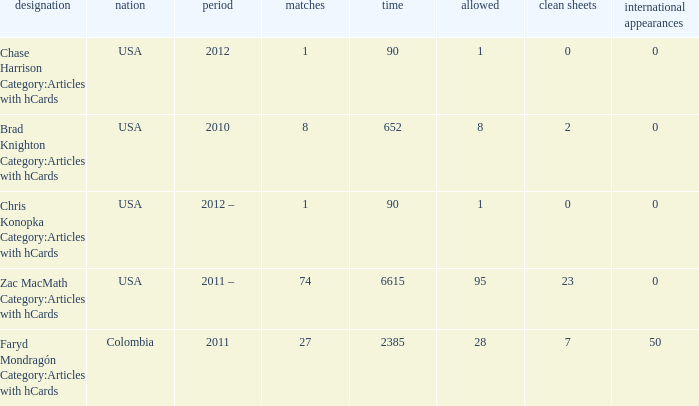Can you parse all the data within this table? {'header': ['designation', 'nation', 'period', 'matches', 'time', 'allowed', 'clean sheets', 'international appearances'], 'rows': [['Chase Harrison Category:Articles with hCards', 'USA', '2012', '1', '90', '1', '0', '0'], ['Brad Knighton Category:Articles with hCards', 'USA', '2010', '8', '652', '8', '2', '0'], ['Chris Konopka Category:Articles with hCards', 'USA', '2012 –', '1', '90', '1', '0', '0'], ['Zac MacMath Category:Articles with hCards', 'USA', '2011 –', '74', '6615', '95', '23', '0'], ['Faryd Mondragón Category:Articles with hCards', 'Colombia', '2011', '27', '2385', '28', '7', '50']]} What is the lowest overall amount of shutouts? 0.0. 